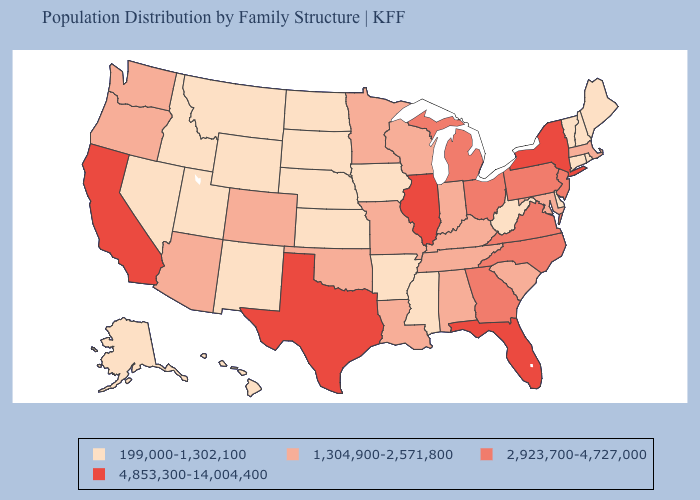Does Tennessee have a higher value than Rhode Island?
Answer briefly. Yes. What is the value of Wisconsin?
Be succinct. 1,304,900-2,571,800. What is the value of Idaho?
Keep it brief. 199,000-1,302,100. Does Delaware have the lowest value in the South?
Short answer required. Yes. Does Nebraska have the lowest value in the MidWest?
Quick response, please. Yes. Name the states that have a value in the range 1,304,900-2,571,800?
Give a very brief answer. Alabama, Arizona, Colorado, Indiana, Kentucky, Louisiana, Maryland, Massachusetts, Minnesota, Missouri, Oklahoma, Oregon, South Carolina, Tennessee, Washington, Wisconsin. Which states hav the highest value in the MidWest?
Be succinct. Illinois. Name the states that have a value in the range 1,304,900-2,571,800?
Quick response, please. Alabama, Arizona, Colorado, Indiana, Kentucky, Louisiana, Maryland, Massachusetts, Minnesota, Missouri, Oklahoma, Oregon, South Carolina, Tennessee, Washington, Wisconsin. Name the states that have a value in the range 2,923,700-4,727,000?
Keep it brief. Georgia, Michigan, New Jersey, North Carolina, Ohio, Pennsylvania, Virginia. Does Colorado have a higher value than Michigan?
Keep it brief. No. Which states hav the highest value in the MidWest?
Be succinct. Illinois. Name the states that have a value in the range 4,853,300-14,004,400?
Short answer required. California, Florida, Illinois, New York, Texas. What is the lowest value in states that border Delaware?
Short answer required. 1,304,900-2,571,800. Does Iowa have the lowest value in the MidWest?
Give a very brief answer. Yes. What is the lowest value in the USA?
Answer briefly. 199,000-1,302,100. 